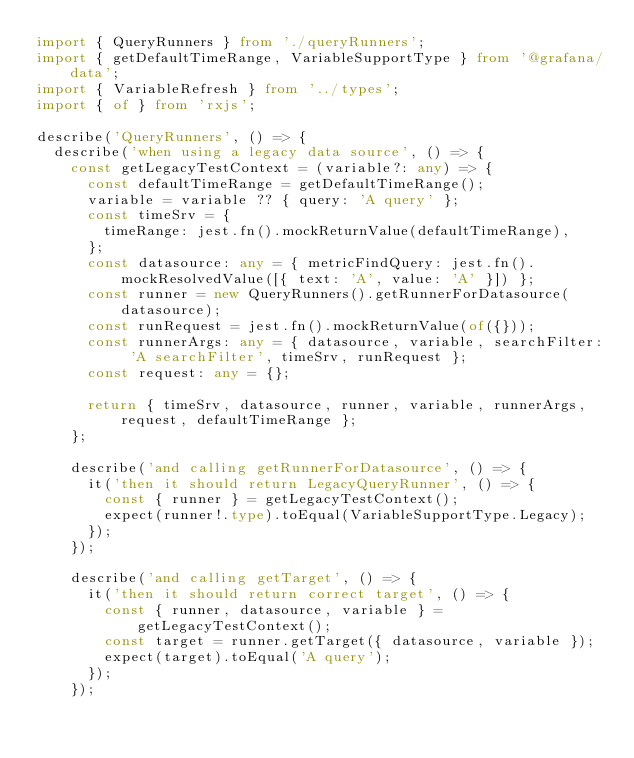<code> <loc_0><loc_0><loc_500><loc_500><_TypeScript_>import { QueryRunners } from './queryRunners';
import { getDefaultTimeRange, VariableSupportType } from '@grafana/data';
import { VariableRefresh } from '../types';
import { of } from 'rxjs';

describe('QueryRunners', () => {
  describe('when using a legacy data source', () => {
    const getLegacyTestContext = (variable?: any) => {
      const defaultTimeRange = getDefaultTimeRange();
      variable = variable ?? { query: 'A query' };
      const timeSrv = {
        timeRange: jest.fn().mockReturnValue(defaultTimeRange),
      };
      const datasource: any = { metricFindQuery: jest.fn().mockResolvedValue([{ text: 'A', value: 'A' }]) };
      const runner = new QueryRunners().getRunnerForDatasource(datasource);
      const runRequest = jest.fn().mockReturnValue(of({}));
      const runnerArgs: any = { datasource, variable, searchFilter: 'A searchFilter', timeSrv, runRequest };
      const request: any = {};

      return { timeSrv, datasource, runner, variable, runnerArgs, request, defaultTimeRange };
    };

    describe('and calling getRunnerForDatasource', () => {
      it('then it should return LegacyQueryRunner', () => {
        const { runner } = getLegacyTestContext();
        expect(runner!.type).toEqual(VariableSupportType.Legacy);
      });
    });

    describe('and calling getTarget', () => {
      it('then it should return correct target', () => {
        const { runner, datasource, variable } = getLegacyTestContext();
        const target = runner.getTarget({ datasource, variable });
        expect(target).toEqual('A query');
      });
    });
</code> 